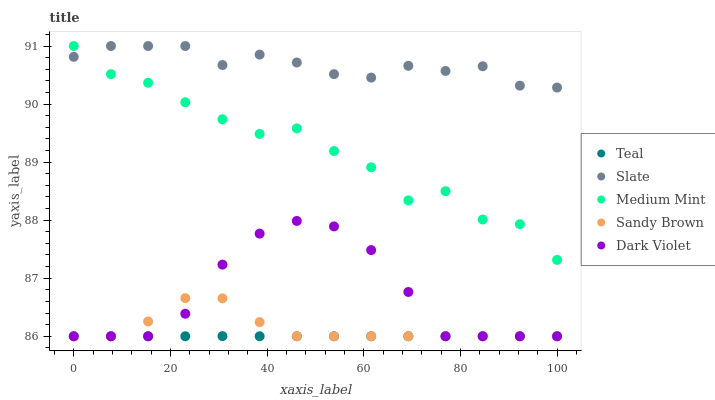Does Teal have the minimum area under the curve?
Answer yes or no. Yes. Does Slate have the maximum area under the curve?
Answer yes or no. Yes. Does Sandy Brown have the minimum area under the curve?
Answer yes or no. No. Does Sandy Brown have the maximum area under the curve?
Answer yes or no. No. Is Teal the smoothest?
Answer yes or no. Yes. Is Medium Mint the roughest?
Answer yes or no. Yes. Is Slate the smoothest?
Answer yes or no. No. Is Slate the roughest?
Answer yes or no. No. Does Sandy Brown have the lowest value?
Answer yes or no. Yes. Does Slate have the lowest value?
Answer yes or no. No. Does Slate have the highest value?
Answer yes or no. Yes. Does Sandy Brown have the highest value?
Answer yes or no. No. Is Sandy Brown less than Medium Mint?
Answer yes or no. Yes. Is Slate greater than Dark Violet?
Answer yes or no. Yes. Does Sandy Brown intersect Dark Violet?
Answer yes or no. Yes. Is Sandy Brown less than Dark Violet?
Answer yes or no. No. Is Sandy Brown greater than Dark Violet?
Answer yes or no. No. Does Sandy Brown intersect Medium Mint?
Answer yes or no. No. 